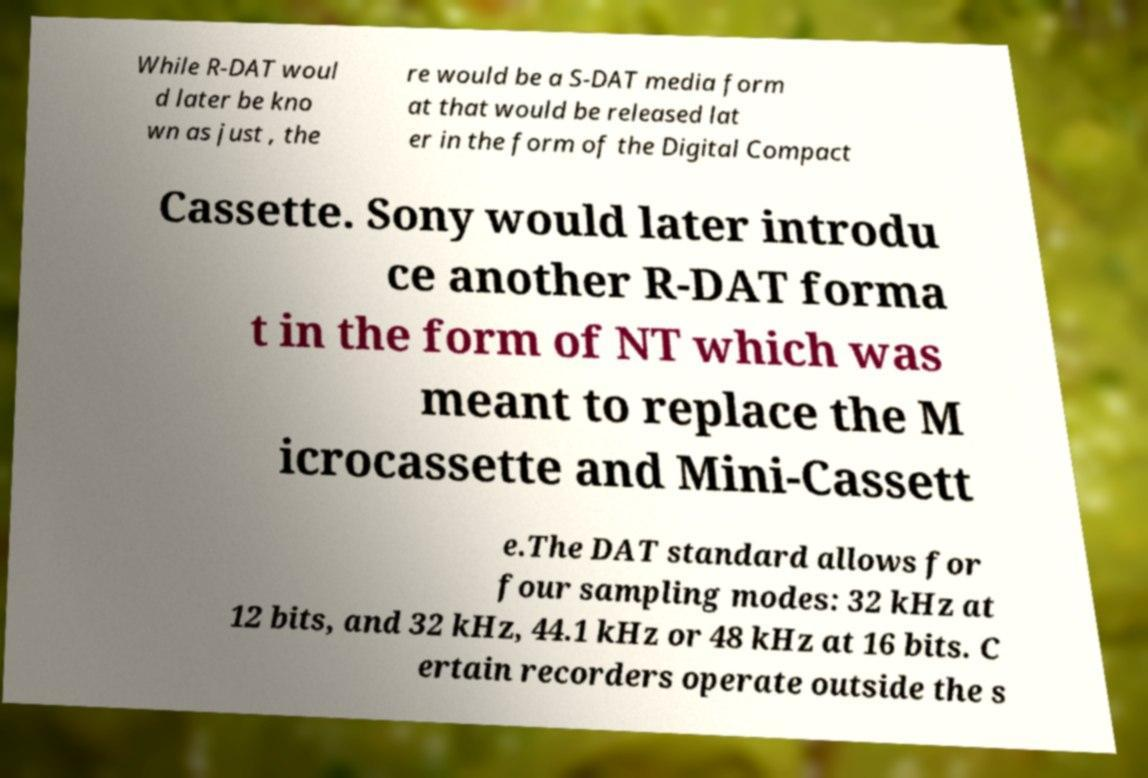Could you assist in decoding the text presented in this image and type it out clearly? While R-DAT woul d later be kno wn as just , the re would be a S-DAT media form at that would be released lat er in the form of the Digital Compact Cassette. Sony would later introdu ce another R-DAT forma t in the form of NT which was meant to replace the M icrocassette and Mini-Cassett e.The DAT standard allows for four sampling modes: 32 kHz at 12 bits, and 32 kHz, 44.1 kHz or 48 kHz at 16 bits. C ertain recorders operate outside the s 